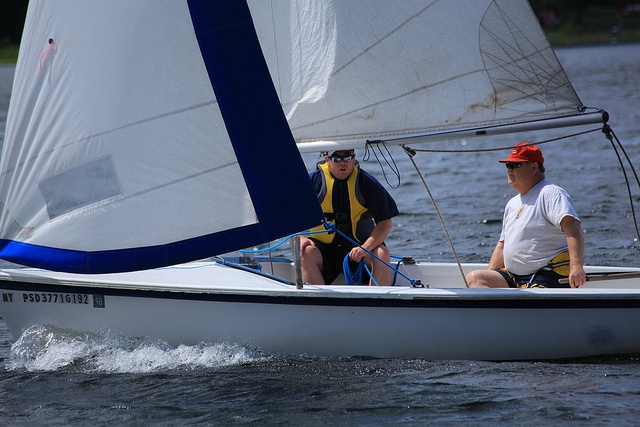Describe the objects in this image and their specific colors. I can see boat in black, darkgray, and gray tones, people in black, gray, lavender, and darkgray tones, and people in black, brown, maroon, and olive tones in this image. 